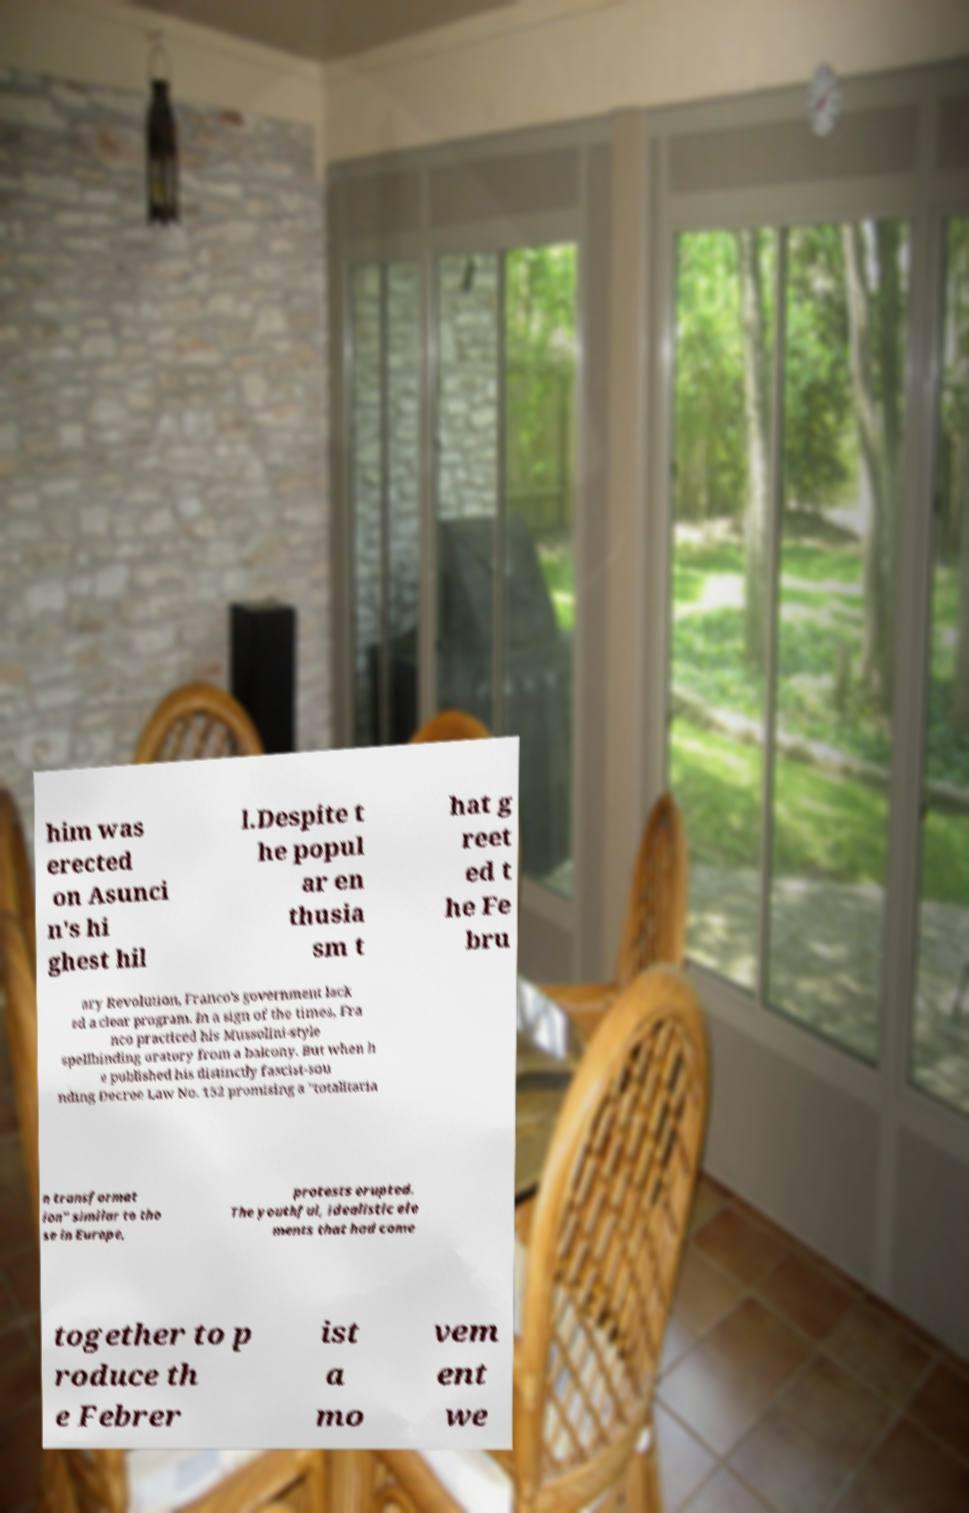Can you accurately transcribe the text from the provided image for me? him was erected on Asunci n's hi ghest hil l.Despite t he popul ar en thusia sm t hat g reet ed t he Fe bru ary Revolution, Franco's government lack ed a clear program. In a sign of the times, Fra nco practiced his Mussolini-style spellbinding oratory from a balcony. But when h e published his distinctly fascist-sou nding Decree Law No. 152 promising a "totalitaria n transformat ion" similar to tho se in Europe, protests erupted. The youthful, idealistic ele ments that had come together to p roduce th e Febrer ist a mo vem ent we 